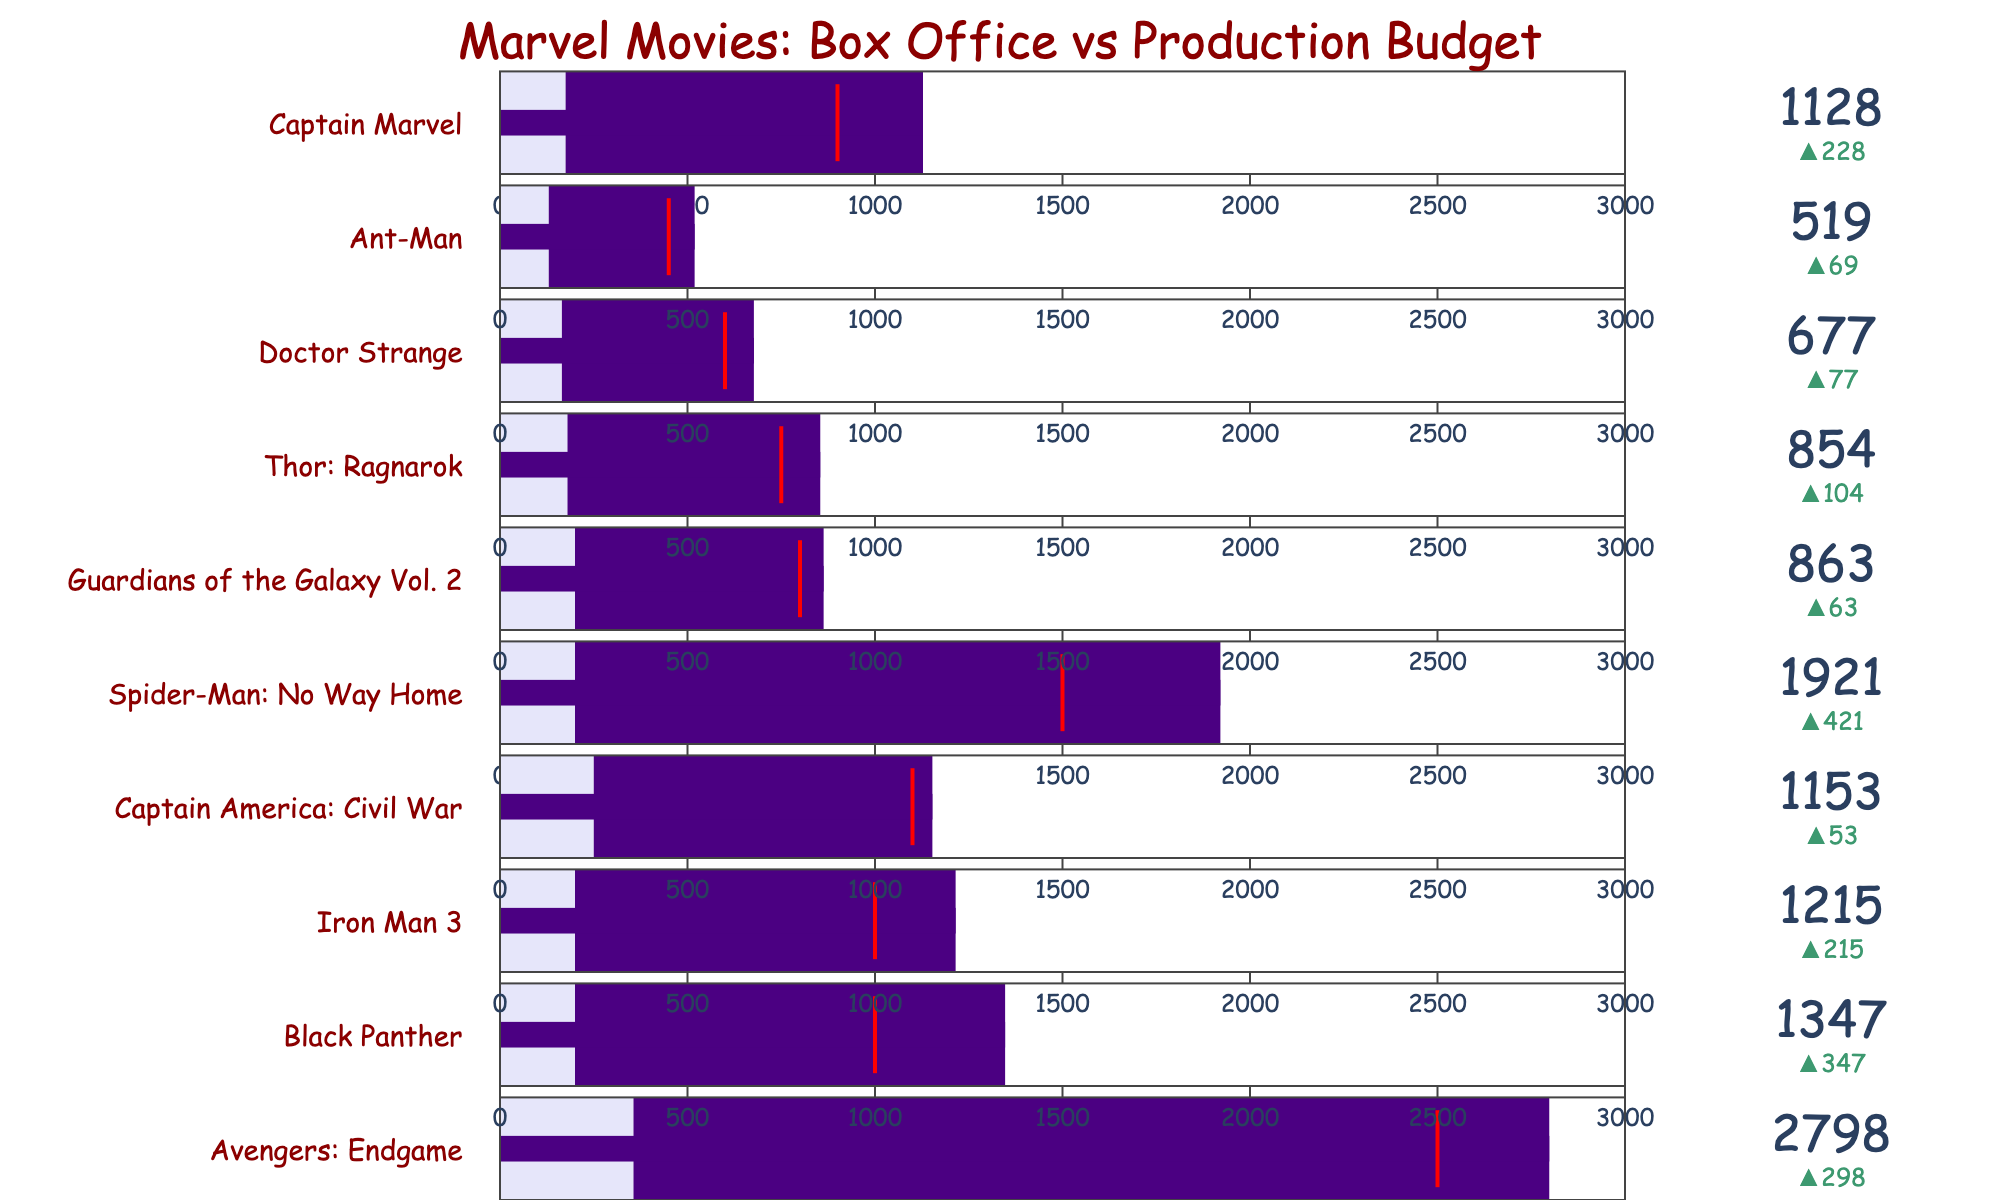How many different Marvel movies are included in the figure? Count the number of different movie titles listed in the chart.
Answer: 10 What is the movie with the highest Box Office revenue? Identify the tallest bar representing the highest Box Office value.
Answer: Avengers: Endgame Which movie has the largest difference between its Box Office revenue and its Production Budget? Look for the movie where the range between the production budget bar and the Box Office bar (purple) is the greatest.
Answer: Avengers: Endgame Did Doctor Strange surpass its target Box Office revenue? Compare the Box Office value (number indicator) for Doctor Strange with its target (threshold marker).
Answer: Yes Which movie underperformed compared to its target? Identify any movie where the Box Office revenue is less than the target (indicated by the red threshold line).
Answer: None What is the combined Box Office revenue of Black Panther and Spider-Man: No Way Home? Add the Box Office revenues of Black Panther (1347) and Spider-Man: No Way Home (1921). 1347 + 1921 = 3268
Answer: 3268 By how much did Captain Marvel exceed its target Box Office revenue? Subtract Captain Marvel's target Box Office (900) from its actual Box Office revenue (1128). 1128 - 900 = 228
Answer: 228 Does any movie have a Production Budget equal to its Box Office revenue? Check if any production budget bar stretches exactly to the same point as the corresponding Box Office bar.
Answer: No Which movie's Box Office revenue was the closest to its target? Identify the movie where the delta (difference) between the Box Office and the target is the smallest.
Answer: Captain America: Civil War In terms of production budget, was Thor: Ragnarok more or less expensive to make than Doctor Strange? Compare the length of the production budget (light lavender) bars of Thor: Ragnarok and Doctor Strange.
Answer: More expensive 